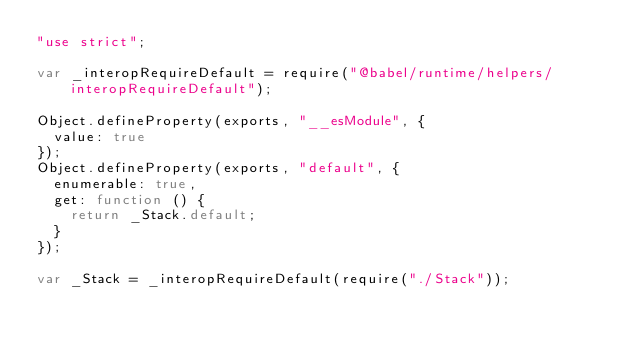Convert code to text. <code><loc_0><loc_0><loc_500><loc_500><_JavaScript_>"use strict";

var _interopRequireDefault = require("@babel/runtime/helpers/interopRequireDefault");

Object.defineProperty(exports, "__esModule", {
  value: true
});
Object.defineProperty(exports, "default", {
  enumerable: true,
  get: function () {
    return _Stack.default;
  }
});

var _Stack = _interopRequireDefault(require("./Stack"));</code> 